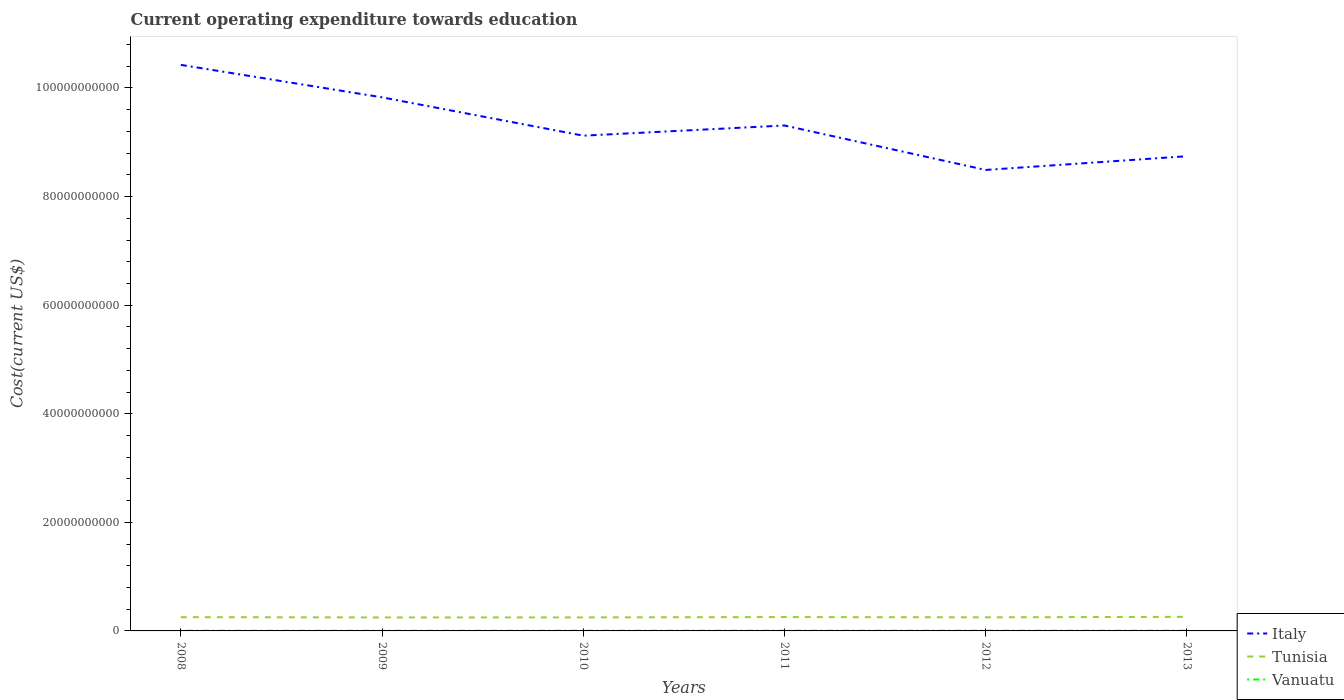Is the number of lines equal to the number of legend labels?
Your response must be concise. Yes. Across all years, what is the maximum expenditure towards education in Vanuatu?
Offer a terse response. 2.93e+07. In which year was the expenditure towards education in Tunisia maximum?
Give a very brief answer. 2009. What is the total expenditure towards education in Italy in the graph?
Offer a terse response. -2.53e+09. What is the difference between the highest and the second highest expenditure towards education in Tunisia?
Make the answer very short. 1.16e+08. What is the difference between the highest and the lowest expenditure towards education in Tunisia?
Provide a succinct answer. 3. Is the expenditure towards education in Vanuatu strictly greater than the expenditure towards education in Tunisia over the years?
Ensure brevity in your answer.  Yes. How many years are there in the graph?
Make the answer very short. 6. Are the values on the major ticks of Y-axis written in scientific E-notation?
Give a very brief answer. No. Where does the legend appear in the graph?
Give a very brief answer. Bottom right. How many legend labels are there?
Provide a short and direct response. 3. What is the title of the graph?
Your answer should be very brief. Current operating expenditure towards education. Does "New Zealand" appear as one of the legend labels in the graph?
Provide a succinct answer. No. What is the label or title of the X-axis?
Keep it short and to the point. Years. What is the label or title of the Y-axis?
Offer a very short reply. Cost(current US$). What is the Cost(current US$) of Italy in 2008?
Offer a terse response. 1.04e+11. What is the Cost(current US$) of Tunisia in 2008?
Give a very brief answer. 2.53e+09. What is the Cost(current US$) of Vanuatu in 2008?
Ensure brevity in your answer.  3.44e+07. What is the Cost(current US$) of Italy in 2009?
Provide a succinct answer. 9.83e+1. What is the Cost(current US$) of Tunisia in 2009?
Keep it short and to the point. 2.48e+09. What is the Cost(current US$) of Vanuatu in 2009?
Make the answer very short. 2.93e+07. What is the Cost(current US$) in Italy in 2010?
Offer a very short reply. 9.12e+1. What is the Cost(current US$) in Tunisia in 2010?
Ensure brevity in your answer.  2.49e+09. What is the Cost(current US$) of Vanuatu in 2010?
Provide a succinct answer. 3.40e+07. What is the Cost(current US$) of Italy in 2011?
Offer a very short reply. 9.31e+1. What is the Cost(current US$) of Tunisia in 2011?
Keep it short and to the point. 2.55e+09. What is the Cost(current US$) in Vanuatu in 2011?
Keep it short and to the point. 3.83e+07. What is the Cost(current US$) of Italy in 2012?
Keep it short and to the point. 8.49e+1. What is the Cost(current US$) in Tunisia in 2012?
Provide a succinct answer. 2.50e+09. What is the Cost(current US$) of Vanuatu in 2012?
Give a very brief answer. 3.73e+07. What is the Cost(current US$) of Italy in 2013?
Offer a terse response. 8.74e+1. What is the Cost(current US$) of Tunisia in 2013?
Ensure brevity in your answer.  2.60e+09. What is the Cost(current US$) of Vanuatu in 2013?
Ensure brevity in your answer.  3.84e+07. Across all years, what is the maximum Cost(current US$) of Italy?
Your response must be concise. 1.04e+11. Across all years, what is the maximum Cost(current US$) of Tunisia?
Offer a terse response. 2.60e+09. Across all years, what is the maximum Cost(current US$) of Vanuatu?
Your answer should be very brief. 3.84e+07. Across all years, what is the minimum Cost(current US$) in Italy?
Your answer should be very brief. 8.49e+1. Across all years, what is the minimum Cost(current US$) in Tunisia?
Provide a succinct answer. 2.48e+09. Across all years, what is the minimum Cost(current US$) in Vanuatu?
Make the answer very short. 2.93e+07. What is the total Cost(current US$) in Italy in the graph?
Your answer should be compact. 5.59e+11. What is the total Cost(current US$) of Tunisia in the graph?
Offer a very short reply. 1.52e+1. What is the total Cost(current US$) in Vanuatu in the graph?
Offer a very short reply. 2.12e+08. What is the difference between the Cost(current US$) of Italy in 2008 and that in 2009?
Provide a succinct answer. 5.98e+09. What is the difference between the Cost(current US$) of Tunisia in 2008 and that in 2009?
Your response must be concise. 5.23e+07. What is the difference between the Cost(current US$) of Vanuatu in 2008 and that in 2009?
Offer a terse response. 5.04e+06. What is the difference between the Cost(current US$) in Italy in 2008 and that in 2010?
Provide a succinct answer. 1.30e+1. What is the difference between the Cost(current US$) of Tunisia in 2008 and that in 2010?
Provide a short and direct response. 4.66e+07. What is the difference between the Cost(current US$) of Vanuatu in 2008 and that in 2010?
Give a very brief answer. 4.28e+05. What is the difference between the Cost(current US$) of Italy in 2008 and that in 2011?
Make the answer very short. 1.12e+1. What is the difference between the Cost(current US$) in Tunisia in 2008 and that in 2011?
Your answer should be very brief. -1.80e+07. What is the difference between the Cost(current US$) in Vanuatu in 2008 and that in 2011?
Provide a short and direct response. -3.90e+06. What is the difference between the Cost(current US$) in Italy in 2008 and that in 2012?
Provide a short and direct response. 1.94e+1. What is the difference between the Cost(current US$) in Tunisia in 2008 and that in 2012?
Ensure brevity in your answer.  3.06e+07. What is the difference between the Cost(current US$) of Vanuatu in 2008 and that in 2012?
Provide a short and direct response. -2.95e+06. What is the difference between the Cost(current US$) of Italy in 2008 and that in 2013?
Your response must be concise. 1.68e+1. What is the difference between the Cost(current US$) in Tunisia in 2008 and that in 2013?
Give a very brief answer. -6.39e+07. What is the difference between the Cost(current US$) of Vanuatu in 2008 and that in 2013?
Your answer should be compact. -4.05e+06. What is the difference between the Cost(current US$) of Italy in 2009 and that in 2010?
Offer a very short reply. 7.06e+09. What is the difference between the Cost(current US$) of Tunisia in 2009 and that in 2010?
Your answer should be very brief. -5.75e+06. What is the difference between the Cost(current US$) of Vanuatu in 2009 and that in 2010?
Your answer should be very brief. -4.61e+06. What is the difference between the Cost(current US$) of Italy in 2009 and that in 2011?
Your answer should be compact. 5.18e+09. What is the difference between the Cost(current US$) in Tunisia in 2009 and that in 2011?
Offer a very short reply. -7.03e+07. What is the difference between the Cost(current US$) in Vanuatu in 2009 and that in 2011?
Give a very brief answer. -8.94e+06. What is the difference between the Cost(current US$) of Italy in 2009 and that in 2012?
Give a very brief answer. 1.34e+1. What is the difference between the Cost(current US$) of Tunisia in 2009 and that in 2012?
Provide a short and direct response. -2.17e+07. What is the difference between the Cost(current US$) in Vanuatu in 2009 and that in 2012?
Give a very brief answer. -7.99e+06. What is the difference between the Cost(current US$) in Italy in 2009 and that in 2013?
Your answer should be very brief. 1.08e+1. What is the difference between the Cost(current US$) in Tunisia in 2009 and that in 2013?
Your answer should be very brief. -1.16e+08. What is the difference between the Cost(current US$) of Vanuatu in 2009 and that in 2013?
Keep it short and to the point. -9.09e+06. What is the difference between the Cost(current US$) in Italy in 2010 and that in 2011?
Your answer should be compact. -1.88e+09. What is the difference between the Cost(current US$) of Tunisia in 2010 and that in 2011?
Make the answer very short. -6.46e+07. What is the difference between the Cost(current US$) in Vanuatu in 2010 and that in 2011?
Provide a succinct answer. -4.33e+06. What is the difference between the Cost(current US$) in Italy in 2010 and that in 2012?
Provide a short and direct response. 6.31e+09. What is the difference between the Cost(current US$) in Tunisia in 2010 and that in 2012?
Keep it short and to the point. -1.60e+07. What is the difference between the Cost(current US$) in Vanuatu in 2010 and that in 2012?
Provide a succinct answer. -3.38e+06. What is the difference between the Cost(current US$) of Italy in 2010 and that in 2013?
Provide a succinct answer. 3.78e+09. What is the difference between the Cost(current US$) in Tunisia in 2010 and that in 2013?
Offer a very short reply. -1.10e+08. What is the difference between the Cost(current US$) of Vanuatu in 2010 and that in 2013?
Offer a very short reply. -4.47e+06. What is the difference between the Cost(current US$) in Italy in 2011 and that in 2012?
Make the answer very short. 8.19e+09. What is the difference between the Cost(current US$) in Tunisia in 2011 and that in 2012?
Your answer should be very brief. 4.86e+07. What is the difference between the Cost(current US$) in Vanuatu in 2011 and that in 2012?
Offer a terse response. 9.54e+05. What is the difference between the Cost(current US$) in Italy in 2011 and that in 2013?
Your answer should be compact. 5.66e+09. What is the difference between the Cost(current US$) of Tunisia in 2011 and that in 2013?
Make the answer very short. -4.59e+07. What is the difference between the Cost(current US$) of Vanuatu in 2011 and that in 2013?
Make the answer very short. -1.45e+05. What is the difference between the Cost(current US$) of Italy in 2012 and that in 2013?
Make the answer very short. -2.53e+09. What is the difference between the Cost(current US$) of Tunisia in 2012 and that in 2013?
Keep it short and to the point. -9.45e+07. What is the difference between the Cost(current US$) of Vanuatu in 2012 and that in 2013?
Ensure brevity in your answer.  -1.10e+06. What is the difference between the Cost(current US$) in Italy in 2008 and the Cost(current US$) in Tunisia in 2009?
Offer a terse response. 1.02e+11. What is the difference between the Cost(current US$) in Italy in 2008 and the Cost(current US$) in Vanuatu in 2009?
Provide a succinct answer. 1.04e+11. What is the difference between the Cost(current US$) of Tunisia in 2008 and the Cost(current US$) of Vanuatu in 2009?
Provide a short and direct response. 2.51e+09. What is the difference between the Cost(current US$) of Italy in 2008 and the Cost(current US$) of Tunisia in 2010?
Keep it short and to the point. 1.02e+11. What is the difference between the Cost(current US$) in Italy in 2008 and the Cost(current US$) in Vanuatu in 2010?
Offer a terse response. 1.04e+11. What is the difference between the Cost(current US$) of Tunisia in 2008 and the Cost(current US$) of Vanuatu in 2010?
Provide a succinct answer. 2.50e+09. What is the difference between the Cost(current US$) in Italy in 2008 and the Cost(current US$) in Tunisia in 2011?
Ensure brevity in your answer.  1.02e+11. What is the difference between the Cost(current US$) of Italy in 2008 and the Cost(current US$) of Vanuatu in 2011?
Provide a succinct answer. 1.04e+11. What is the difference between the Cost(current US$) in Tunisia in 2008 and the Cost(current US$) in Vanuatu in 2011?
Offer a very short reply. 2.50e+09. What is the difference between the Cost(current US$) of Italy in 2008 and the Cost(current US$) of Tunisia in 2012?
Ensure brevity in your answer.  1.02e+11. What is the difference between the Cost(current US$) of Italy in 2008 and the Cost(current US$) of Vanuatu in 2012?
Make the answer very short. 1.04e+11. What is the difference between the Cost(current US$) in Tunisia in 2008 and the Cost(current US$) in Vanuatu in 2012?
Offer a very short reply. 2.50e+09. What is the difference between the Cost(current US$) of Italy in 2008 and the Cost(current US$) of Tunisia in 2013?
Offer a very short reply. 1.02e+11. What is the difference between the Cost(current US$) in Italy in 2008 and the Cost(current US$) in Vanuatu in 2013?
Provide a short and direct response. 1.04e+11. What is the difference between the Cost(current US$) of Tunisia in 2008 and the Cost(current US$) of Vanuatu in 2013?
Your response must be concise. 2.50e+09. What is the difference between the Cost(current US$) in Italy in 2009 and the Cost(current US$) in Tunisia in 2010?
Provide a short and direct response. 9.58e+1. What is the difference between the Cost(current US$) of Italy in 2009 and the Cost(current US$) of Vanuatu in 2010?
Your answer should be very brief. 9.82e+1. What is the difference between the Cost(current US$) of Tunisia in 2009 and the Cost(current US$) of Vanuatu in 2010?
Ensure brevity in your answer.  2.45e+09. What is the difference between the Cost(current US$) of Italy in 2009 and the Cost(current US$) of Tunisia in 2011?
Provide a short and direct response. 9.57e+1. What is the difference between the Cost(current US$) in Italy in 2009 and the Cost(current US$) in Vanuatu in 2011?
Ensure brevity in your answer.  9.82e+1. What is the difference between the Cost(current US$) in Tunisia in 2009 and the Cost(current US$) in Vanuatu in 2011?
Give a very brief answer. 2.44e+09. What is the difference between the Cost(current US$) in Italy in 2009 and the Cost(current US$) in Tunisia in 2012?
Give a very brief answer. 9.58e+1. What is the difference between the Cost(current US$) in Italy in 2009 and the Cost(current US$) in Vanuatu in 2012?
Provide a short and direct response. 9.82e+1. What is the difference between the Cost(current US$) in Tunisia in 2009 and the Cost(current US$) in Vanuatu in 2012?
Ensure brevity in your answer.  2.44e+09. What is the difference between the Cost(current US$) of Italy in 2009 and the Cost(current US$) of Tunisia in 2013?
Provide a short and direct response. 9.57e+1. What is the difference between the Cost(current US$) in Italy in 2009 and the Cost(current US$) in Vanuatu in 2013?
Give a very brief answer. 9.82e+1. What is the difference between the Cost(current US$) in Tunisia in 2009 and the Cost(current US$) in Vanuatu in 2013?
Offer a very short reply. 2.44e+09. What is the difference between the Cost(current US$) in Italy in 2010 and the Cost(current US$) in Tunisia in 2011?
Ensure brevity in your answer.  8.87e+1. What is the difference between the Cost(current US$) in Italy in 2010 and the Cost(current US$) in Vanuatu in 2011?
Give a very brief answer. 9.12e+1. What is the difference between the Cost(current US$) in Tunisia in 2010 and the Cost(current US$) in Vanuatu in 2011?
Keep it short and to the point. 2.45e+09. What is the difference between the Cost(current US$) in Italy in 2010 and the Cost(current US$) in Tunisia in 2012?
Offer a terse response. 8.87e+1. What is the difference between the Cost(current US$) of Italy in 2010 and the Cost(current US$) of Vanuatu in 2012?
Give a very brief answer. 9.12e+1. What is the difference between the Cost(current US$) in Tunisia in 2010 and the Cost(current US$) in Vanuatu in 2012?
Keep it short and to the point. 2.45e+09. What is the difference between the Cost(current US$) of Italy in 2010 and the Cost(current US$) of Tunisia in 2013?
Offer a very short reply. 8.86e+1. What is the difference between the Cost(current US$) in Italy in 2010 and the Cost(current US$) in Vanuatu in 2013?
Your answer should be very brief. 9.12e+1. What is the difference between the Cost(current US$) of Tunisia in 2010 and the Cost(current US$) of Vanuatu in 2013?
Your answer should be very brief. 2.45e+09. What is the difference between the Cost(current US$) in Italy in 2011 and the Cost(current US$) in Tunisia in 2012?
Ensure brevity in your answer.  9.06e+1. What is the difference between the Cost(current US$) of Italy in 2011 and the Cost(current US$) of Vanuatu in 2012?
Keep it short and to the point. 9.31e+1. What is the difference between the Cost(current US$) in Tunisia in 2011 and the Cost(current US$) in Vanuatu in 2012?
Ensure brevity in your answer.  2.52e+09. What is the difference between the Cost(current US$) of Italy in 2011 and the Cost(current US$) of Tunisia in 2013?
Ensure brevity in your answer.  9.05e+1. What is the difference between the Cost(current US$) of Italy in 2011 and the Cost(current US$) of Vanuatu in 2013?
Offer a very short reply. 9.31e+1. What is the difference between the Cost(current US$) in Tunisia in 2011 and the Cost(current US$) in Vanuatu in 2013?
Your response must be concise. 2.51e+09. What is the difference between the Cost(current US$) of Italy in 2012 and the Cost(current US$) of Tunisia in 2013?
Ensure brevity in your answer.  8.23e+1. What is the difference between the Cost(current US$) of Italy in 2012 and the Cost(current US$) of Vanuatu in 2013?
Ensure brevity in your answer.  8.49e+1. What is the difference between the Cost(current US$) of Tunisia in 2012 and the Cost(current US$) of Vanuatu in 2013?
Your response must be concise. 2.47e+09. What is the average Cost(current US$) of Italy per year?
Make the answer very short. 9.32e+1. What is the average Cost(current US$) in Tunisia per year?
Keep it short and to the point. 2.53e+09. What is the average Cost(current US$) in Vanuatu per year?
Provide a short and direct response. 3.53e+07. In the year 2008, what is the difference between the Cost(current US$) of Italy and Cost(current US$) of Tunisia?
Your response must be concise. 1.02e+11. In the year 2008, what is the difference between the Cost(current US$) of Italy and Cost(current US$) of Vanuatu?
Offer a terse response. 1.04e+11. In the year 2008, what is the difference between the Cost(current US$) of Tunisia and Cost(current US$) of Vanuatu?
Keep it short and to the point. 2.50e+09. In the year 2009, what is the difference between the Cost(current US$) in Italy and Cost(current US$) in Tunisia?
Your response must be concise. 9.58e+1. In the year 2009, what is the difference between the Cost(current US$) of Italy and Cost(current US$) of Vanuatu?
Ensure brevity in your answer.  9.82e+1. In the year 2009, what is the difference between the Cost(current US$) in Tunisia and Cost(current US$) in Vanuatu?
Your response must be concise. 2.45e+09. In the year 2010, what is the difference between the Cost(current US$) of Italy and Cost(current US$) of Tunisia?
Provide a succinct answer. 8.87e+1. In the year 2010, what is the difference between the Cost(current US$) of Italy and Cost(current US$) of Vanuatu?
Provide a short and direct response. 9.12e+1. In the year 2010, what is the difference between the Cost(current US$) in Tunisia and Cost(current US$) in Vanuatu?
Give a very brief answer. 2.45e+09. In the year 2011, what is the difference between the Cost(current US$) in Italy and Cost(current US$) in Tunisia?
Provide a short and direct response. 9.05e+1. In the year 2011, what is the difference between the Cost(current US$) in Italy and Cost(current US$) in Vanuatu?
Give a very brief answer. 9.31e+1. In the year 2011, what is the difference between the Cost(current US$) in Tunisia and Cost(current US$) in Vanuatu?
Make the answer very short. 2.51e+09. In the year 2012, what is the difference between the Cost(current US$) of Italy and Cost(current US$) of Tunisia?
Keep it short and to the point. 8.24e+1. In the year 2012, what is the difference between the Cost(current US$) of Italy and Cost(current US$) of Vanuatu?
Offer a terse response. 8.49e+1. In the year 2012, what is the difference between the Cost(current US$) of Tunisia and Cost(current US$) of Vanuatu?
Provide a short and direct response. 2.47e+09. In the year 2013, what is the difference between the Cost(current US$) of Italy and Cost(current US$) of Tunisia?
Ensure brevity in your answer.  8.48e+1. In the year 2013, what is the difference between the Cost(current US$) in Italy and Cost(current US$) in Vanuatu?
Your answer should be compact. 8.74e+1. In the year 2013, what is the difference between the Cost(current US$) of Tunisia and Cost(current US$) of Vanuatu?
Your answer should be compact. 2.56e+09. What is the ratio of the Cost(current US$) of Italy in 2008 to that in 2009?
Give a very brief answer. 1.06. What is the ratio of the Cost(current US$) of Tunisia in 2008 to that in 2009?
Make the answer very short. 1.02. What is the ratio of the Cost(current US$) in Vanuatu in 2008 to that in 2009?
Make the answer very short. 1.17. What is the ratio of the Cost(current US$) of Italy in 2008 to that in 2010?
Keep it short and to the point. 1.14. What is the ratio of the Cost(current US$) in Tunisia in 2008 to that in 2010?
Your answer should be compact. 1.02. What is the ratio of the Cost(current US$) in Vanuatu in 2008 to that in 2010?
Make the answer very short. 1.01. What is the ratio of the Cost(current US$) of Italy in 2008 to that in 2011?
Provide a succinct answer. 1.12. What is the ratio of the Cost(current US$) in Tunisia in 2008 to that in 2011?
Your response must be concise. 0.99. What is the ratio of the Cost(current US$) of Vanuatu in 2008 to that in 2011?
Keep it short and to the point. 0.9. What is the ratio of the Cost(current US$) in Italy in 2008 to that in 2012?
Offer a very short reply. 1.23. What is the ratio of the Cost(current US$) in Tunisia in 2008 to that in 2012?
Your response must be concise. 1.01. What is the ratio of the Cost(current US$) in Vanuatu in 2008 to that in 2012?
Your answer should be very brief. 0.92. What is the ratio of the Cost(current US$) in Italy in 2008 to that in 2013?
Your response must be concise. 1.19. What is the ratio of the Cost(current US$) of Tunisia in 2008 to that in 2013?
Make the answer very short. 0.98. What is the ratio of the Cost(current US$) of Vanuatu in 2008 to that in 2013?
Provide a short and direct response. 0.89. What is the ratio of the Cost(current US$) of Italy in 2009 to that in 2010?
Offer a terse response. 1.08. What is the ratio of the Cost(current US$) of Tunisia in 2009 to that in 2010?
Ensure brevity in your answer.  1. What is the ratio of the Cost(current US$) in Vanuatu in 2009 to that in 2010?
Your answer should be compact. 0.86. What is the ratio of the Cost(current US$) in Italy in 2009 to that in 2011?
Your answer should be very brief. 1.06. What is the ratio of the Cost(current US$) of Tunisia in 2009 to that in 2011?
Your answer should be very brief. 0.97. What is the ratio of the Cost(current US$) in Vanuatu in 2009 to that in 2011?
Ensure brevity in your answer.  0.77. What is the ratio of the Cost(current US$) in Italy in 2009 to that in 2012?
Your response must be concise. 1.16. What is the ratio of the Cost(current US$) of Tunisia in 2009 to that in 2012?
Offer a terse response. 0.99. What is the ratio of the Cost(current US$) of Vanuatu in 2009 to that in 2012?
Ensure brevity in your answer.  0.79. What is the ratio of the Cost(current US$) in Italy in 2009 to that in 2013?
Keep it short and to the point. 1.12. What is the ratio of the Cost(current US$) of Tunisia in 2009 to that in 2013?
Offer a very short reply. 0.96. What is the ratio of the Cost(current US$) in Vanuatu in 2009 to that in 2013?
Provide a short and direct response. 0.76. What is the ratio of the Cost(current US$) in Italy in 2010 to that in 2011?
Offer a terse response. 0.98. What is the ratio of the Cost(current US$) of Tunisia in 2010 to that in 2011?
Your answer should be compact. 0.97. What is the ratio of the Cost(current US$) of Vanuatu in 2010 to that in 2011?
Ensure brevity in your answer.  0.89. What is the ratio of the Cost(current US$) of Italy in 2010 to that in 2012?
Offer a terse response. 1.07. What is the ratio of the Cost(current US$) of Tunisia in 2010 to that in 2012?
Your answer should be very brief. 0.99. What is the ratio of the Cost(current US$) in Vanuatu in 2010 to that in 2012?
Your answer should be very brief. 0.91. What is the ratio of the Cost(current US$) in Italy in 2010 to that in 2013?
Ensure brevity in your answer.  1.04. What is the ratio of the Cost(current US$) in Tunisia in 2010 to that in 2013?
Provide a succinct answer. 0.96. What is the ratio of the Cost(current US$) in Vanuatu in 2010 to that in 2013?
Ensure brevity in your answer.  0.88. What is the ratio of the Cost(current US$) in Italy in 2011 to that in 2012?
Offer a very short reply. 1.1. What is the ratio of the Cost(current US$) in Tunisia in 2011 to that in 2012?
Provide a succinct answer. 1.02. What is the ratio of the Cost(current US$) of Vanuatu in 2011 to that in 2012?
Provide a succinct answer. 1.03. What is the ratio of the Cost(current US$) of Italy in 2011 to that in 2013?
Offer a very short reply. 1.06. What is the ratio of the Cost(current US$) of Tunisia in 2011 to that in 2013?
Your answer should be very brief. 0.98. What is the ratio of the Cost(current US$) of Italy in 2012 to that in 2013?
Make the answer very short. 0.97. What is the ratio of the Cost(current US$) of Tunisia in 2012 to that in 2013?
Your response must be concise. 0.96. What is the ratio of the Cost(current US$) of Vanuatu in 2012 to that in 2013?
Offer a very short reply. 0.97. What is the difference between the highest and the second highest Cost(current US$) of Italy?
Make the answer very short. 5.98e+09. What is the difference between the highest and the second highest Cost(current US$) of Tunisia?
Give a very brief answer. 4.59e+07. What is the difference between the highest and the second highest Cost(current US$) of Vanuatu?
Provide a succinct answer. 1.45e+05. What is the difference between the highest and the lowest Cost(current US$) in Italy?
Offer a very short reply. 1.94e+1. What is the difference between the highest and the lowest Cost(current US$) in Tunisia?
Your answer should be very brief. 1.16e+08. What is the difference between the highest and the lowest Cost(current US$) in Vanuatu?
Provide a succinct answer. 9.09e+06. 